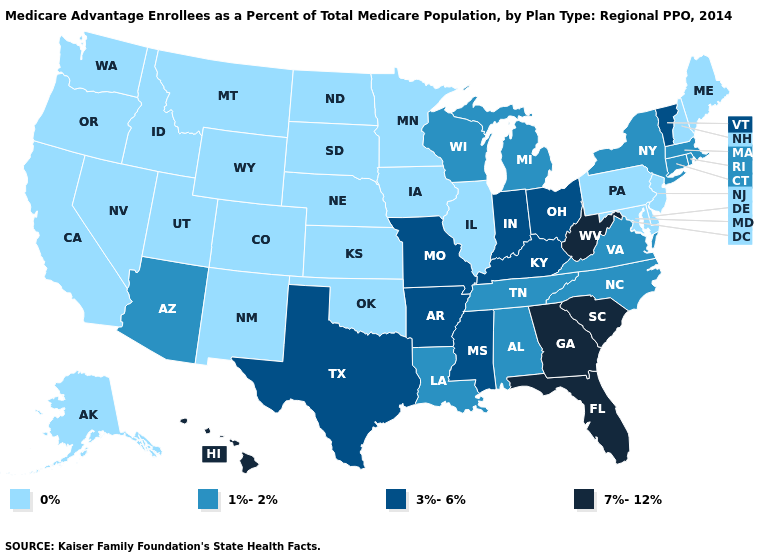Does Ohio have the lowest value in the MidWest?
Write a very short answer. No. Is the legend a continuous bar?
Concise answer only. No. How many symbols are there in the legend?
Concise answer only. 4. Which states have the lowest value in the USA?
Concise answer only. Alaska, California, Colorado, Delaware, Iowa, Idaho, Illinois, Kansas, Maryland, Maine, Minnesota, Montana, North Dakota, Nebraska, New Hampshire, New Jersey, New Mexico, Nevada, Oklahoma, Oregon, Pennsylvania, South Dakota, Utah, Washington, Wyoming. Name the states that have a value in the range 3%-6%?
Concise answer only. Arkansas, Indiana, Kentucky, Missouri, Mississippi, Ohio, Texas, Vermont. What is the highest value in the USA?
Quick response, please. 7%-12%. What is the lowest value in the Northeast?
Be succinct. 0%. Name the states that have a value in the range 1%-2%?
Keep it brief. Alabama, Arizona, Connecticut, Louisiana, Massachusetts, Michigan, North Carolina, New York, Rhode Island, Tennessee, Virginia, Wisconsin. Which states have the highest value in the USA?
Write a very short answer. Florida, Georgia, Hawaii, South Carolina, West Virginia. Among the states that border New Mexico , which have the highest value?
Short answer required. Texas. Which states have the highest value in the USA?
Keep it brief. Florida, Georgia, Hawaii, South Carolina, West Virginia. What is the value of Iowa?
Give a very brief answer. 0%. Name the states that have a value in the range 0%?
Answer briefly. Alaska, California, Colorado, Delaware, Iowa, Idaho, Illinois, Kansas, Maryland, Maine, Minnesota, Montana, North Dakota, Nebraska, New Hampshire, New Jersey, New Mexico, Nevada, Oklahoma, Oregon, Pennsylvania, South Dakota, Utah, Washington, Wyoming. Among the states that border South Carolina , does North Carolina have the highest value?
Concise answer only. No. Name the states that have a value in the range 7%-12%?
Give a very brief answer. Florida, Georgia, Hawaii, South Carolina, West Virginia. 